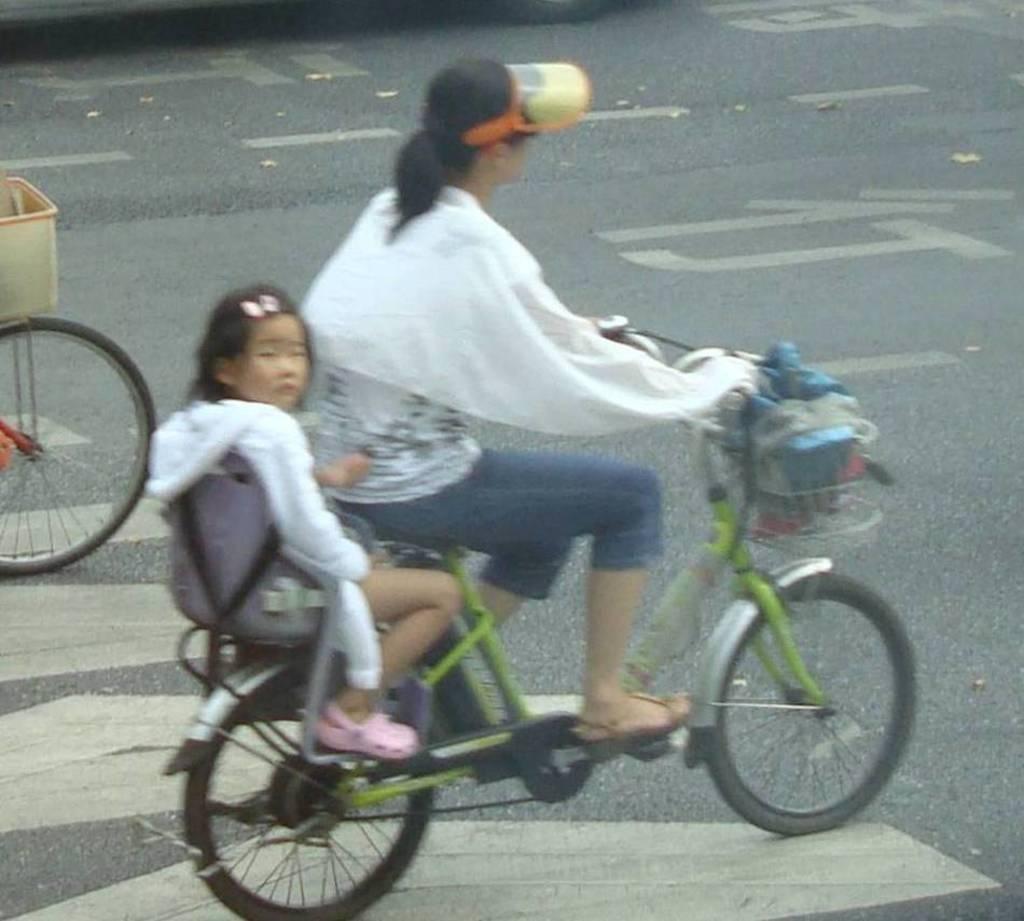Please provide a concise description of this image. In this picture in the middle, we can see two people, one woman is riding the bicycle and other girl is sitting on the bicycle. On the left side, there is another bicycle on the road. In the background, we can see a road. 